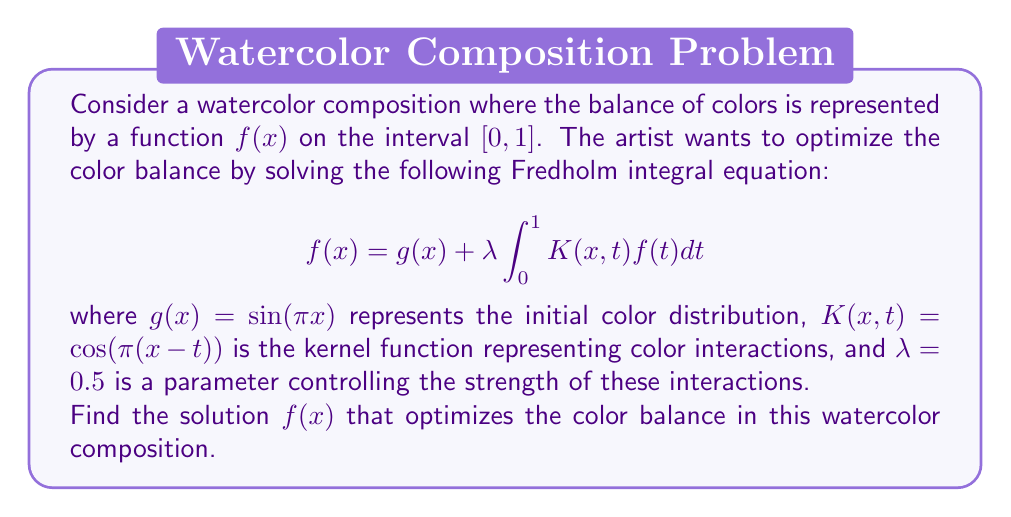Solve this math problem. To solve this Fredholm integral equation, we'll follow these steps:

1) First, we assume that the solution has the form:
   $$f(x) = A\sin(\pi x)$$
   where $A$ is a constant to be determined.

2) Substitute this assumed solution into the integral equation:
   $$A\sin(\pi x) = \sin(\pi x) + 0.5 \int_0^1 \cos(\pi(x-t))A\sin(\pi t)dt$$

3) Simplify the right-hand side of the equation:
   $$\sin(\pi x) + 0.5A \int_0^1 [\cos(\pi x)\cos(\pi t) + \sin(\pi x)\sin(\pi t)]\sin(\pi t)dt$$

4) Evaluate the integrals:
   $$\int_0^1 \cos(\pi t)\sin(\pi t)dt = 0$$
   $$\int_0^1 \sin^2(\pi t)dt = \frac{1}{2}$$

5) After evaluation, the equation becomes:
   $$A\sin(\pi x) = \sin(\pi x) + 0.5A\sin(\pi x)\cdot\frac{1}{2}$$

6) Collect terms with $A\sin(\pi x)$:
   $$A\sin(\pi x) - 0.25A\sin(\pi x) = \sin(\pi x)$$
   $$0.75A\sin(\pi x) = \sin(\pi x)$$

7) Solve for $A$:
   $$A = \frac{1}{0.75} = \frac{4}{3}$$

Therefore, the solution that optimizes the color balance is:
$$f(x) = \frac{4}{3}\sin(\pi x)$$
Answer: $f(x) = \frac{4}{3}\sin(\pi x)$ 